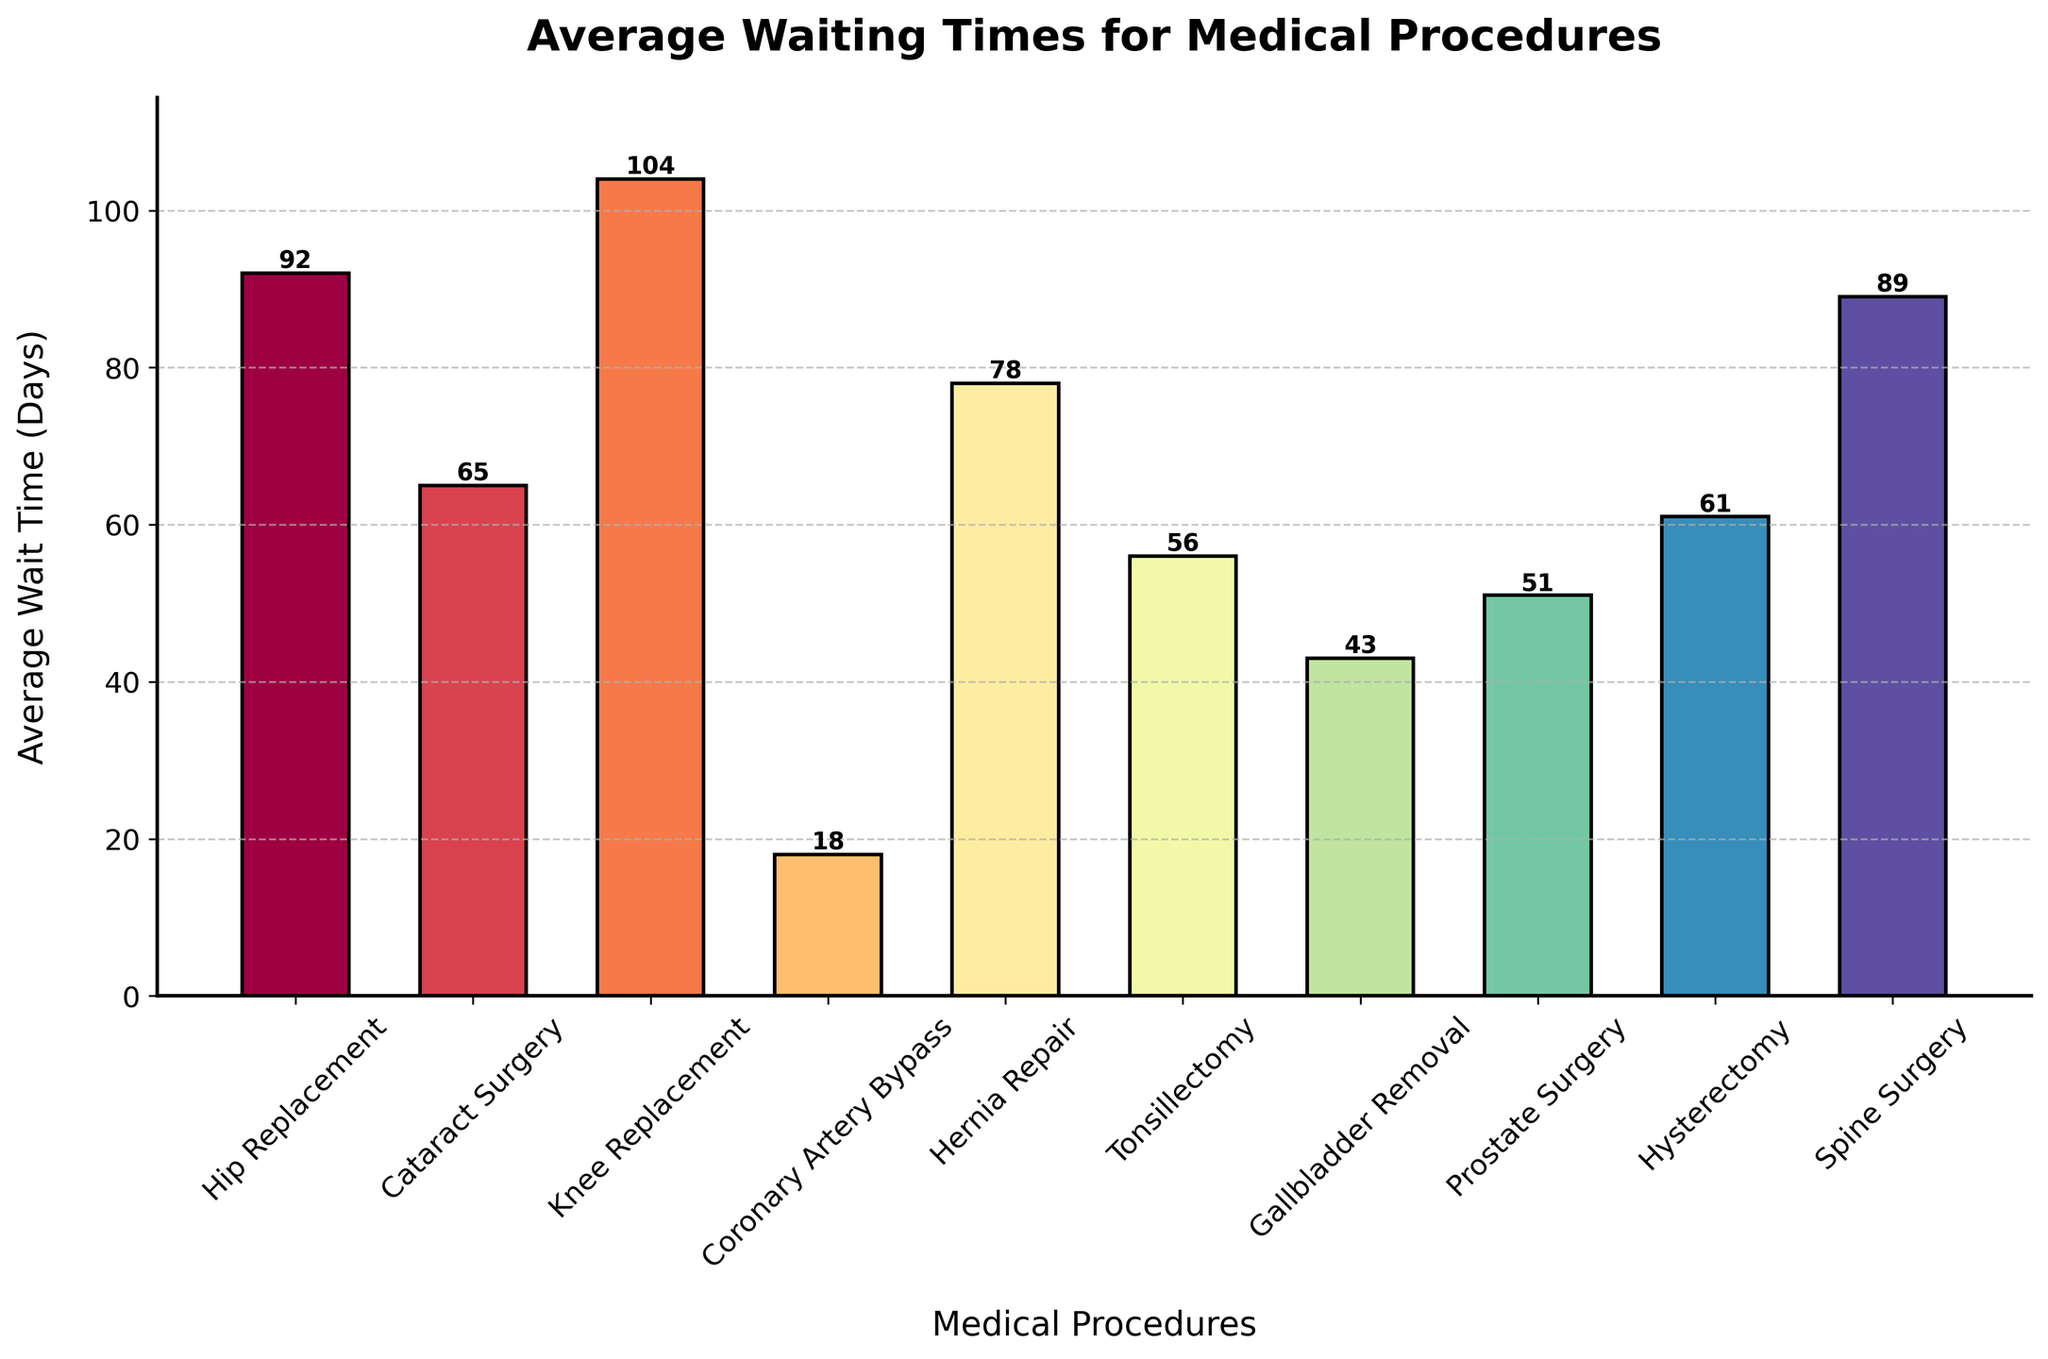Which medical procedure has the longest average waiting time? Identify the tallest bar in the bar chart and find the associated medical procedure label on the x-axis.
Answer: Knee Replacement Which procedure has a shorter average waiting time, Gallbladder Removal or Tonsillectomy? Find the bars corresponding to Gallbladder Removal and Tonsillectomy then compare their heights. Gallbladder Removal has a shorter bar, indicating a shorter wait time.
Answer: Gallbladder Removal What's the difference in average waiting time between Hip Replacement and Prostate Surgery? Look at the bars for Hip Replacement and Prostate Surgery and note their heights. Subtract the shorter height (Prostate Surgery) from the taller height (Hip Replacement). 92 - 51 = 41 days
Answer: 41 days Which medical procedures have an average waiting time below 60 days? Identify the bars with heights below the 60-day mark and note their corresponding procedures. They are Coronary Artery Bypass, Gallbladder Removal, Prostate Surgery, and Tonsillectomy.
Answer: Coronary Artery Bypass, Gallbladder Removal, Prostate Surgery, Tonsillectomy What is the sum of the average waiting times for Hip Replacement and Spine Surgery? Find the heights of the bars for Hip Replacement and Spine Surgery and add them together. 92 + 89 = 181 days
Answer: 181 days Are there more procedures with average waiting times above or below 50 days? Count the number of bars above the 50-day mark and compare it to the number of bars below the 50-day mark. Above 50 days: 7 procedures. Below 50 days: 3 procedures.
Answer: More procedures above 50 days How much longer is the average waiting time for Hysterectomy compared to Gallbladder Removal? Find the heights of the bars for Hysterectomy and Gallbladder Removal and calculate the difference. 61 - 43 = 18 days
Answer: 18 days What is the combined average waiting time for Cataract Surgery, Tonsillectomy, and Hysterectomy? Sum the heights of the bars for Cataract Surgery, Tonsillectomy, and Hysterectomy. 65 + 56 + 61 = 182 days
Answer: 182 days Which procedure has the closest average waiting time to 60 days? Identify the bar with a height closest to 60 days. The Hysterectomy bar is closest, at 61 days.
Answer: Hysterectomy 